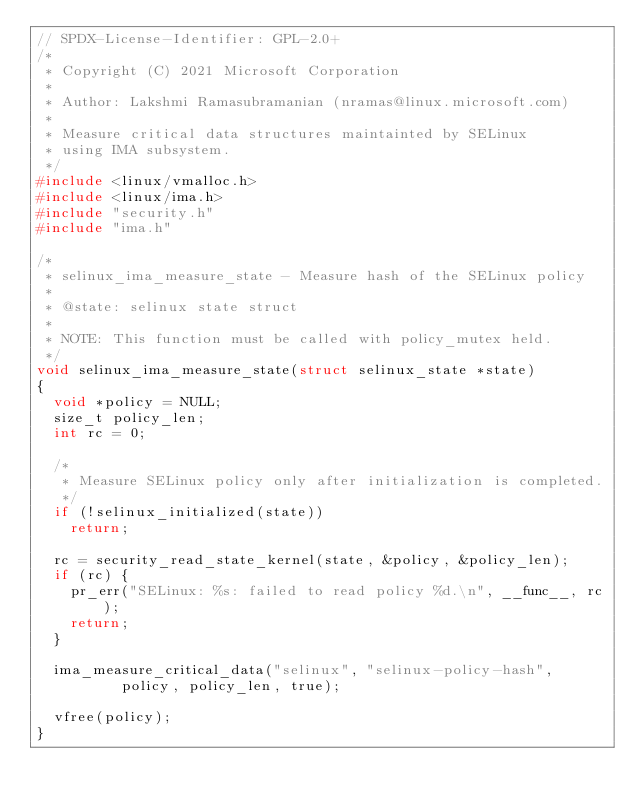Convert code to text. <code><loc_0><loc_0><loc_500><loc_500><_C_>// SPDX-License-Identifier: GPL-2.0+
/*
 * Copyright (C) 2021 Microsoft Corporation
 *
 * Author: Lakshmi Ramasubramanian (nramas@linux.microsoft.com)
 *
 * Measure critical data structures maintainted by SELinux
 * using IMA subsystem.
 */
#include <linux/vmalloc.h>
#include <linux/ima.h>
#include "security.h"
#include "ima.h"

/*
 * selinux_ima_measure_state - Measure hash of the SELinux policy
 *
 * @state: selinux state struct
 *
 * NOTE: This function must be called with policy_mutex held.
 */
void selinux_ima_measure_state(struct selinux_state *state)
{
	void *policy = NULL;
	size_t policy_len;
	int rc = 0;

	/*
	 * Measure SELinux policy only after initialization is completed.
	 */
	if (!selinux_initialized(state))
		return;

	rc = security_read_state_kernel(state, &policy, &policy_len);
	if (rc) {
		pr_err("SELinux: %s: failed to read policy %d.\n", __func__, rc);
		return;
	}

	ima_measure_critical_data("selinux", "selinux-policy-hash",
				  policy, policy_len, true);

	vfree(policy);
}
</code> 